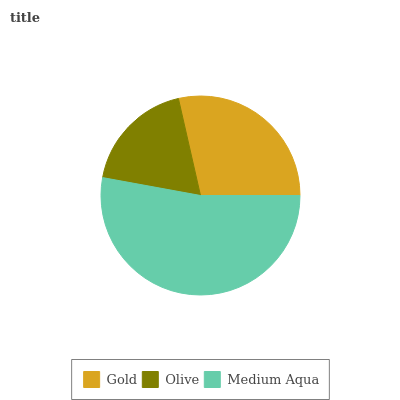Is Olive the minimum?
Answer yes or no. Yes. Is Medium Aqua the maximum?
Answer yes or no. Yes. Is Medium Aqua the minimum?
Answer yes or no. No. Is Olive the maximum?
Answer yes or no. No. Is Medium Aqua greater than Olive?
Answer yes or no. Yes. Is Olive less than Medium Aqua?
Answer yes or no. Yes. Is Olive greater than Medium Aqua?
Answer yes or no. No. Is Medium Aqua less than Olive?
Answer yes or no. No. Is Gold the high median?
Answer yes or no. Yes. Is Gold the low median?
Answer yes or no. Yes. Is Olive the high median?
Answer yes or no. No. Is Olive the low median?
Answer yes or no. No. 